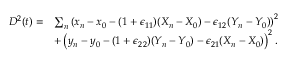Convert formula to latex. <formula><loc_0><loc_0><loc_500><loc_500>\begin{array} { r l } { D ^ { 2 } ( t ) = } & { \sum _ { n } \left ( x _ { n } - x _ { 0 } - ( 1 + \epsilon _ { 1 1 } ) ( X _ { n } - X _ { 0 } ) - \epsilon _ { 1 2 } ( Y _ { n } - Y _ { 0 } ) \right ) ^ { 2 } } \\ & { + \left ( y _ { n } - y _ { 0 } - ( 1 + \epsilon _ { 2 2 } ) ( Y _ { n } - Y _ { 0 } ) - \epsilon _ { 2 1 } ( X _ { n } - X _ { 0 } ) \right ) ^ { 2 } . } \end{array}</formula> 